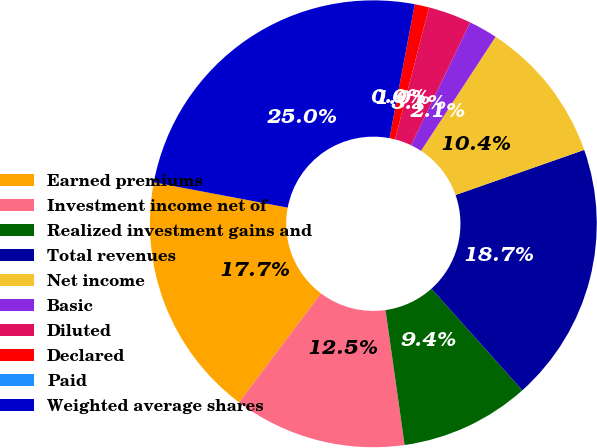<chart> <loc_0><loc_0><loc_500><loc_500><pie_chart><fcel>Earned premiums<fcel>Investment income net of<fcel>Realized investment gains and<fcel>Total revenues<fcel>Net income<fcel>Basic<fcel>Diluted<fcel>Declared<fcel>Paid<fcel>Weighted average shares<nl><fcel>17.71%<fcel>12.5%<fcel>9.38%<fcel>18.75%<fcel>10.42%<fcel>2.08%<fcel>3.13%<fcel>1.04%<fcel>0.0%<fcel>25.0%<nl></chart> 